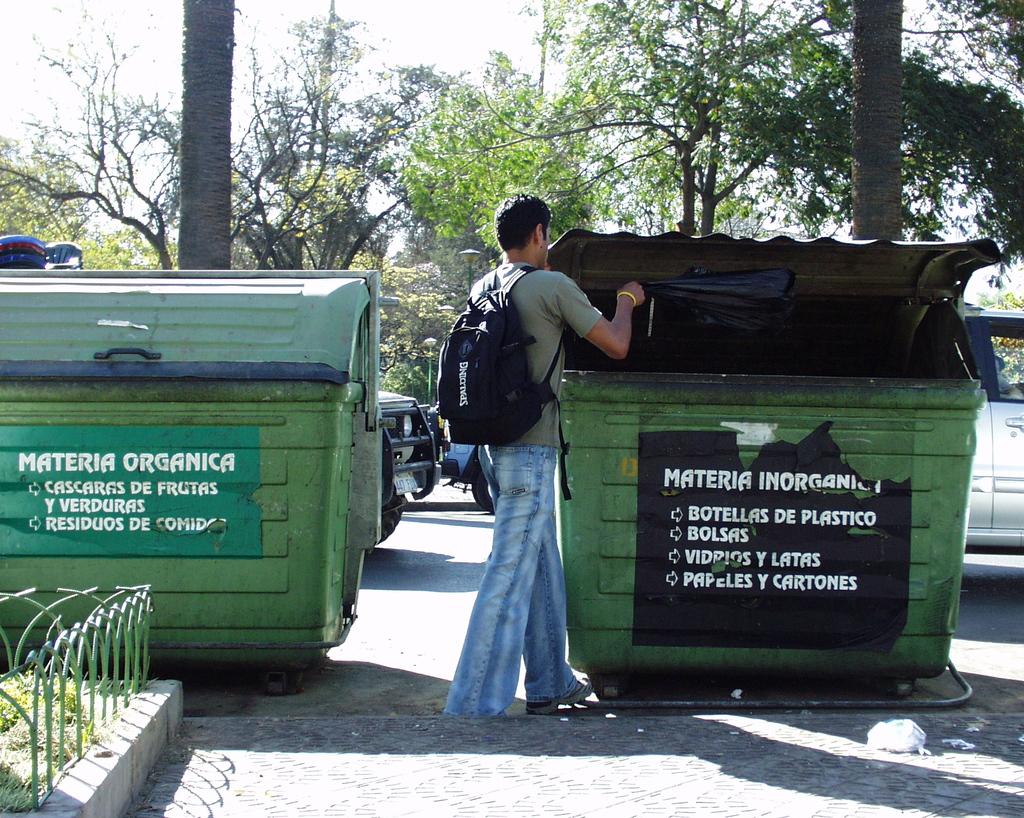Is this a dump bin?
Ensure brevity in your answer.  Answering does not require reading text in the image. What is written on the first line of the leftmost bin?
Make the answer very short. Materia organica. 